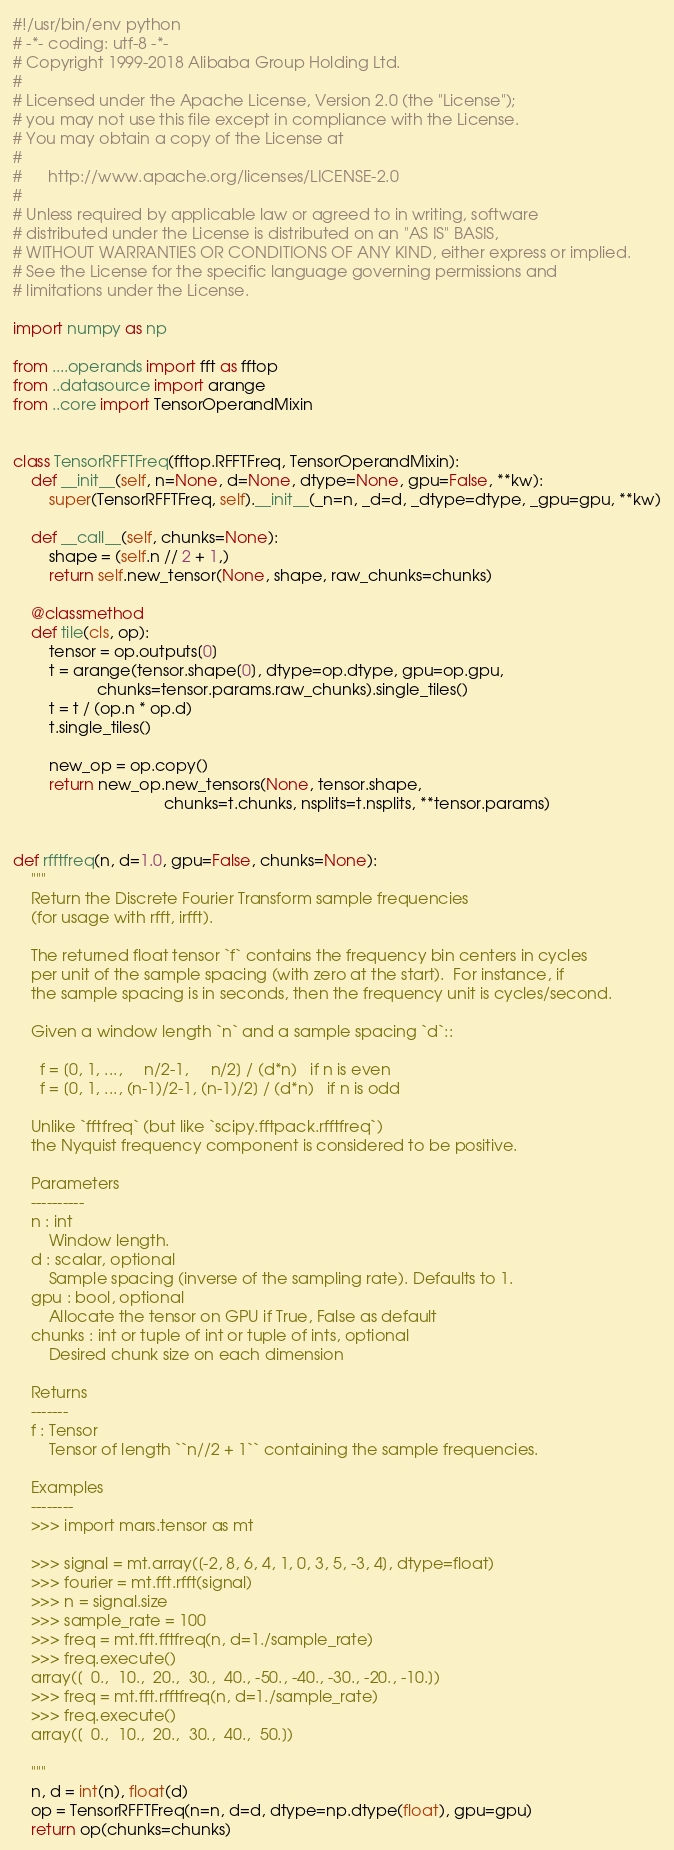Convert code to text. <code><loc_0><loc_0><loc_500><loc_500><_Python_>#!/usr/bin/env python
# -*- coding: utf-8 -*-
# Copyright 1999-2018 Alibaba Group Holding Ltd.
#
# Licensed under the Apache License, Version 2.0 (the "License");
# you may not use this file except in compliance with the License.
# You may obtain a copy of the License at
#
#      http://www.apache.org/licenses/LICENSE-2.0
#
# Unless required by applicable law or agreed to in writing, software
# distributed under the License is distributed on an "AS IS" BASIS,
# WITHOUT WARRANTIES OR CONDITIONS OF ANY KIND, either express or implied.
# See the License for the specific language governing permissions and
# limitations under the License.

import numpy as np

from ....operands import fft as fftop
from ..datasource import arange
from ..core import TensorOperandMixin


class TensorRFFTFreq(fftop.RFFTFreq, TensorOperandMixin):
    def __init__(self, n=None, d=None, dtype=None, gpu=False, **kw):
        super(TensorRFFTFreq, self).__init__(_n=n, _d=d, _dtype=dtype, _gpu=gpu, **kw)

    def __call__(self, chunks=None):
        shape = (self.n // 2 + 1,)
        return self.new_tensor(None, shape, raw_chunks=chunks)

    @classmethod
    def tile(cls, op):
        tensor = op.outputs[0]
        t = arange(tensor.shape[0], dtype=op.dtype, gpu=op.gpu,
                   chunks=tensor.params.raw_chunks).single_tiles()
        t = t / (op.n * op.d)
        t.single_tiles()

        new_op = op.copy()
        return new_op.new_tensors(None, tensor.shape,
                                  chunks=t.chunks, nsplits=t.nsplits, **tensor.params)


def rfftfreq(n, d=1.0, gpu=False, chunks=None):
    """
    Return the Discrete Fourier Transform sample frequencies
    (for usage with rfft, irfft).

    The returned float tensor `f` contains the frequency bin centers in cycles
    per unit of the sample spacing (with zero at the start).  For instance, if
    the sample spacing is in seconds, then the frequency unit is cycles/second.

    Given a window length `n` and a sample spacing `d`::

      f = [0, 1, ...,     n/2-1,     n/2] / (d*n)   if n is even
      f = [0, 1, ..., (n-1)/2-1, (n-1)/2] / (d*n)   if n is odd

    Unlike `fftfreq` (but like `scipy.fftpack.rfftfreq`)
    the Nyquist frequency component is considered to be positive.

    Parameters
    ----------
    n : int
        Window length.
    d : scalar, optional
        Sample spacing (inverse of the sampling rate). Defaults to 1.
    gpu : bool, optional
        Allocate the tensor on GPU if True, False as default
    chunks : int or tuple of int or tuple of ints, optional
        Desired chunk size on each dimension

    Returns
    -------
    f : Tensor
        Tensor of length ``n//2 + 1`` containing the sample frequencies.

    Examples
    --------
    >>> import mars.tensor as mt

    >>> signal = mt.array([-2, 8, 6, 4, 1, 0, 3, 5, -3, 4], dtype=float)
    >>> fourier = mt.fft.rfft(signal)
    >>> n = signal.size
    >>> sample_rate = 100
    >>> freq = mt.fft.fftfreq(n, d=1./sample_rate)
    >>> freq.execute()
    array([  0.,  10.,  20.,  30.,  40., -50., -40., -30., -20., -10.])
    >>> freq = mt.fft.rfftfreq(n, d=1./sample_rate)
    >>> freq.execute()
    array([  0.,  10.,  20.,  30.,  40.,  50.])

    """
    n, d = int(n), float(d)
    op = TensorRFFTFreq(n=n, d=d, dtype=np.dtype(float), gpu=gpu)
    return op(chunks=chunks)
</code> 